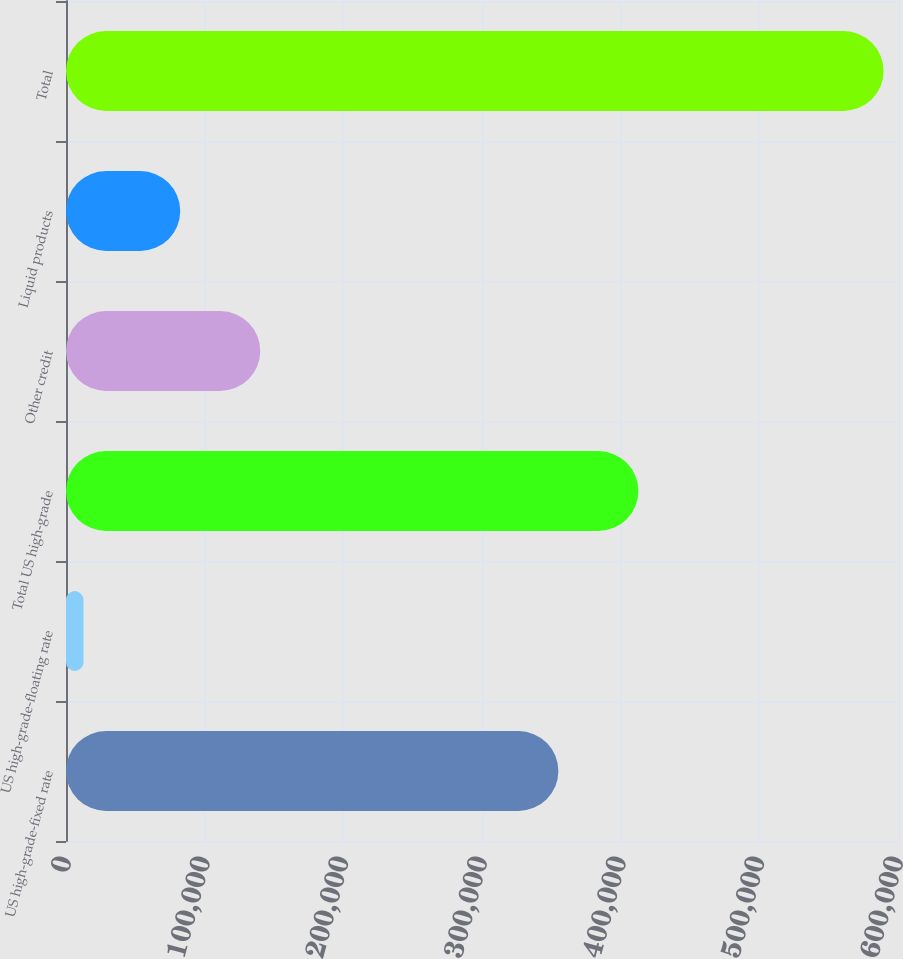<chart> <loc_0><loc_0><loc_500><loc_500><bar_chart><fcel>US high-grade-fixed rate<fcel>US high-grade-floating rate<fcel>Total US high-grade<fcel>Other credit<fcel>Liquid products<fcel>Total<nl><fcel>355087<fcel>12603<fcel>412786<fcel>140079<fcel>82380<fcel>589596<nl></chart> 